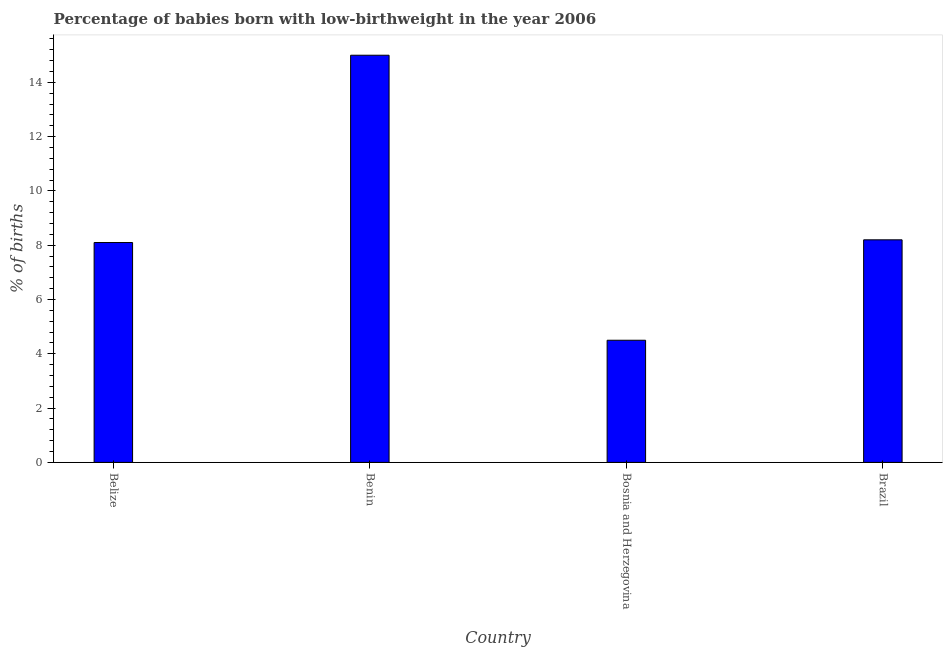What is the title of the graph?
Offer a terse response. Percentage of babies born with low-birthweight in the year 2006. What is the label or title of the Y-axis?
Offer a terse response. % of births. What is the percentage of babies who were born with low-birthweight in Brazil?
Ensure brevity in your answer.  8.2. Across all countries, what is the maximum percentage of babies who were born with low-birthweight?
Make the answer very short. 15. Across all countries, what is the minimum percentage of babies who were born with low-birthweight?
Your response must be concise. 4.5. In which country was the percentage of babies who were born with low-birthweight maximum?
Your answer should be compact. Benin. In which country was the percentage of babies who were born with low-birthweight minimum?
Your answer should be very brief. Bosnia and Herzegovina. What is the sum of the percentage of babies who were born with low-birthweight?
Give a very brief answer. 35.8. What is the difference between the percentage of babies who were born with low-birthweight in Benin and Brazil?
Ensure brevity in your answer.  6.8. What is the average percentage of babies who were born with low-birthweight per country?
Offer a terse response. 8.95. What is the median percentage of babies who were born with low-birthweight?
Provide a short and direct response. 8.15. In how many countries, is the percentage of babies who were born with low-birthweight greater than 2 %?
Your response must be concise. 4. Is the percentage of babies who were born with low-birthweight in Benin less than that in Brazil?
Give a very brief answer. No. Is the difference between the percentage of babies who were born with low-birthweight in Belize and Benin greater than the difference between any two countries?
Keep it short and to the point. No. What is the difference between the highest and the second highest percentage of babies who were born with low-birthweight?
Offer a terse response. 6.8. What is the difference between the highest and the lowest percentage of babies who were born with low-birthweight?
Your response must be concise. 10.5. In how many countries, is the percentage of babies who were born with low-birthweight greater than the average percentage of babies who were born with low-birthweight taken over all countries?
Make the answer very short. 1. How many bars are there?
Make the answer very short. 4. Are all the bars in the graph horizontal?
Offer a very short reply. No. How many countries are there in the graph?
Keep it short and to the point. 4. What is the % of births of Belize?
Offer a terse response. 8.1. What is the % of births of Benin?
Give a very brief answer. 15. What is the % of births in Bosnia and Herzegovina?
Ensure brevity in your answer.  4.5. What is the difference between the % of births in Belize and Brazil?
Offer a terse response. -0.1. What is the difference between the % of births in Benin and Brazil?
Your answer should be compact. 6.8. What is the ratio of the % of births in Belize to that in Benin?
Offer a very short reply. 0.54. What is the ratio of the % of births in Belize to that in Bosnia and Herzegovina?
Your answer should be very brief. 1.8. What is the ratio of the % of births in Belize to that in Brazil?
Offer a terse response. 0.99. What is the ratio of the % of births in Benin to that in Bosnia and Herzegovina?
Your answer should be compact. 3.33. What is the ratio of the % of births in Benin to that in Brazil?
Your answer should be very brief. 1.83. What is the ratio of the % of births in Bosnia and Herzegovina to that in Brazil?
Provide a short and direct response. 0.55. 